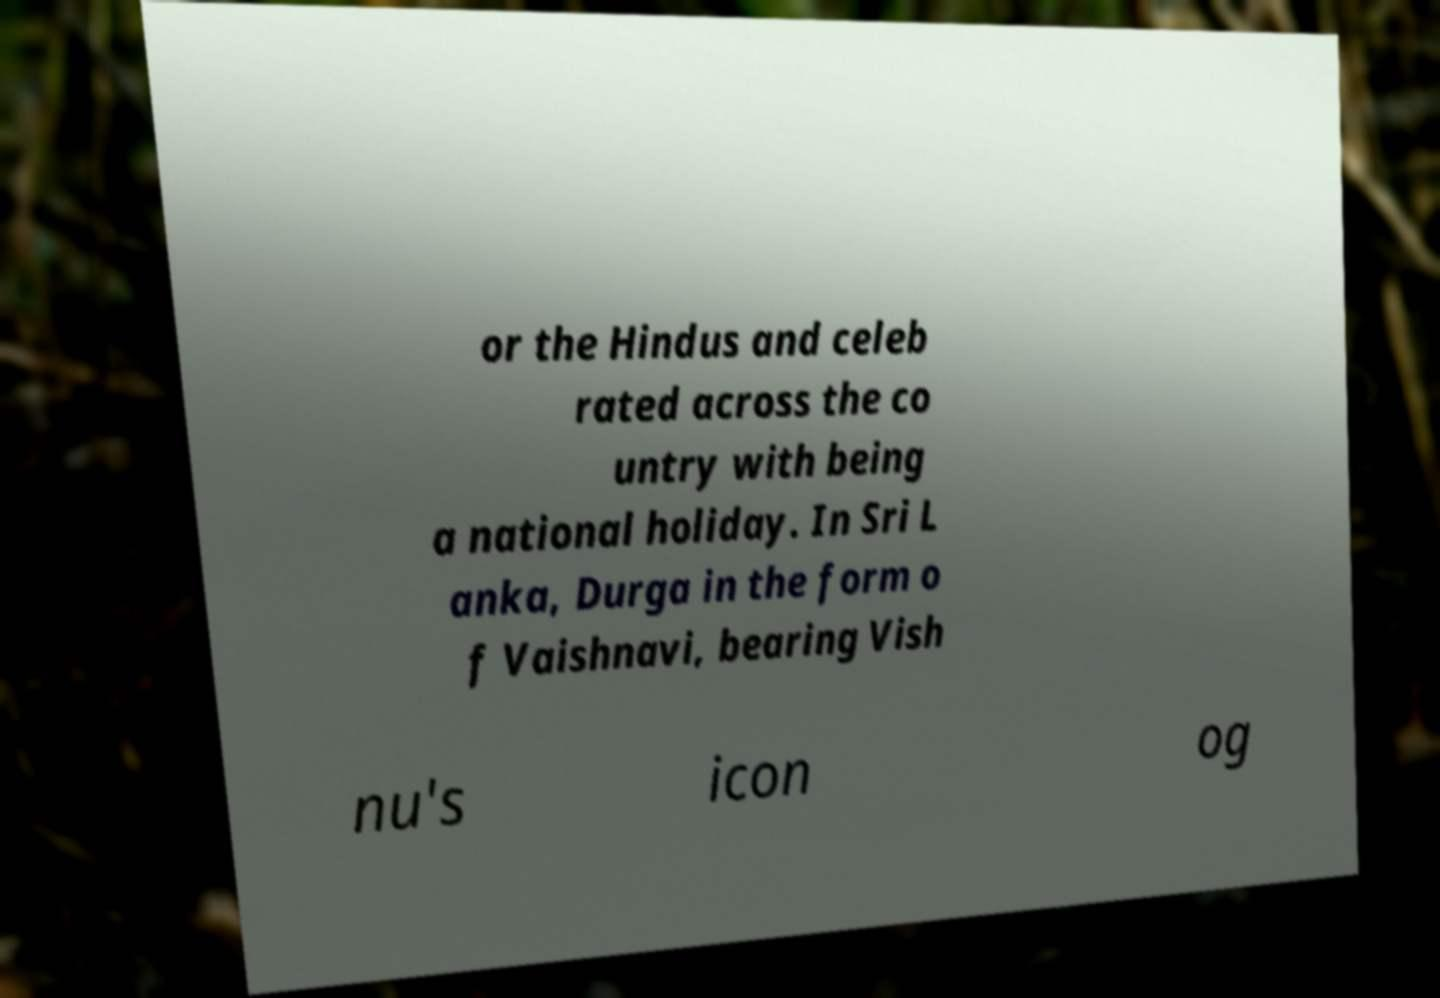Please identify and transcribe the text found in this image. or the Hindus and celeb rated across the co untry with being a national holiday. In Sri L anka, Durga in the form o f Vaishnavi, bearing Vish nu's icon og 